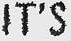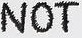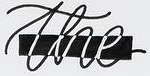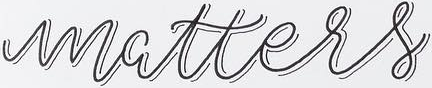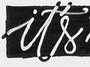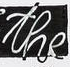Read the text content from these images in order, separated by a semicolon. IT'S; NOT; the; matters; it's; the 